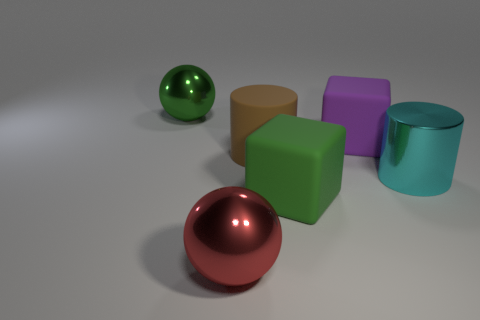Add 2 small purple cubes. How many objects exist? 8 Subtract all cylinders. How many objects are left? 4 Add 3 small red shiny cylinders. How many small red shiny cylinders exist? 3 Subtract 0 purple cylinders. How many objects are left? 6 Subtract all big brown metal cylinders. Subtract all big purple objects. How many objects are left? 5 Add 2 big green metal spheres. How many big green metal spheres are left? 3 